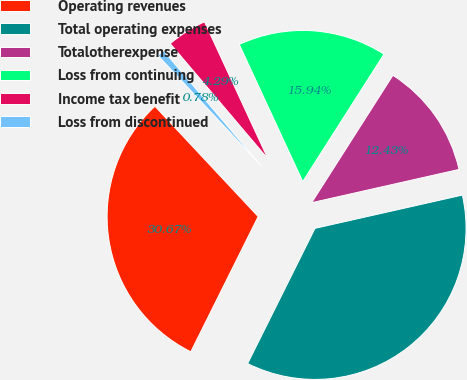<chart> <loc_0><loc_0><loc_500><loc_500><pie_chart><fcel>Operating revenues<fcel>Total operating expenses<fcel>Totalotherexpense<fcel>Loss from continuing<fcel>Income tax benefit<fcel>Loss from discontinued<nl><fcel>30.67%<fcel>35.89%<fcel>12.43%<fcel>15.94%<fcel>4.29%<fcel>0.78%<nl></chart> 